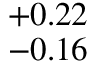Convert formula to latex. <formula><loc_0><loc_0><loc_500><loc_500>^ { + 0 . 2 2 } _ { - 0 . 1 6 }</formula> 